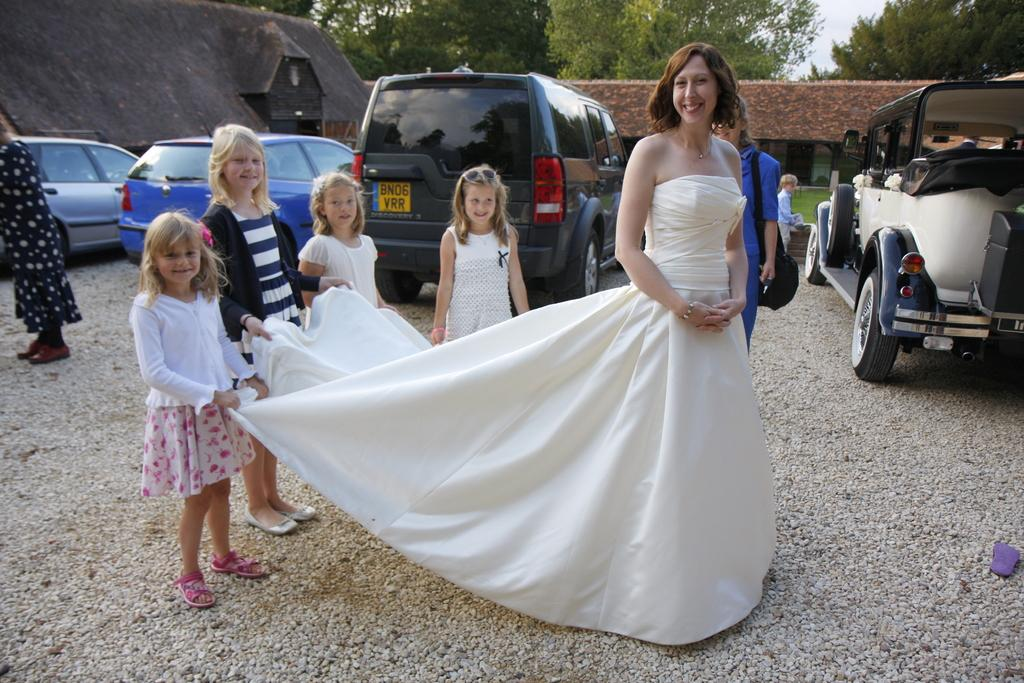Who is the main subject in the image? There is a woman in the image. What is the woman wearing? The woman is wearing a white dress. What are the kids in the image doing? The kids are holding the woman's dress. What can be seen in the background of the image? There are cars, houses, and trees in the background of the image. Where is the playground located in the image? There is no playground present in the image. What type of popcorn is being served at the park in the image? There is no park or popcorn present in the image. 